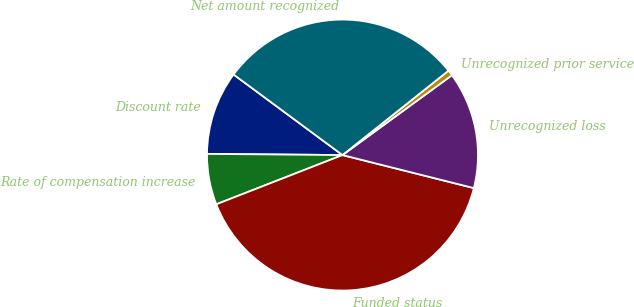<chart> <loc_0><loc_0><loc_500><loc_500><pie_chart><fcel>Discount rate<fcel>Rate of compensation increase<fcel>Funded status<fcel>Unrecognized loss<fcel>Unrecognized prior service<fcel>Net amount recognized<nl><fcel>10.0%<fcel>6.06%<fcel>40.15%<fcel>13.95%<fcel>0.67%<fcel>29.16%<nl></chart> 